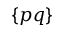Convert formula to latex. <formula><loc_0><loc_0><loc_500><loc_500>\{ p q \}</formula> 